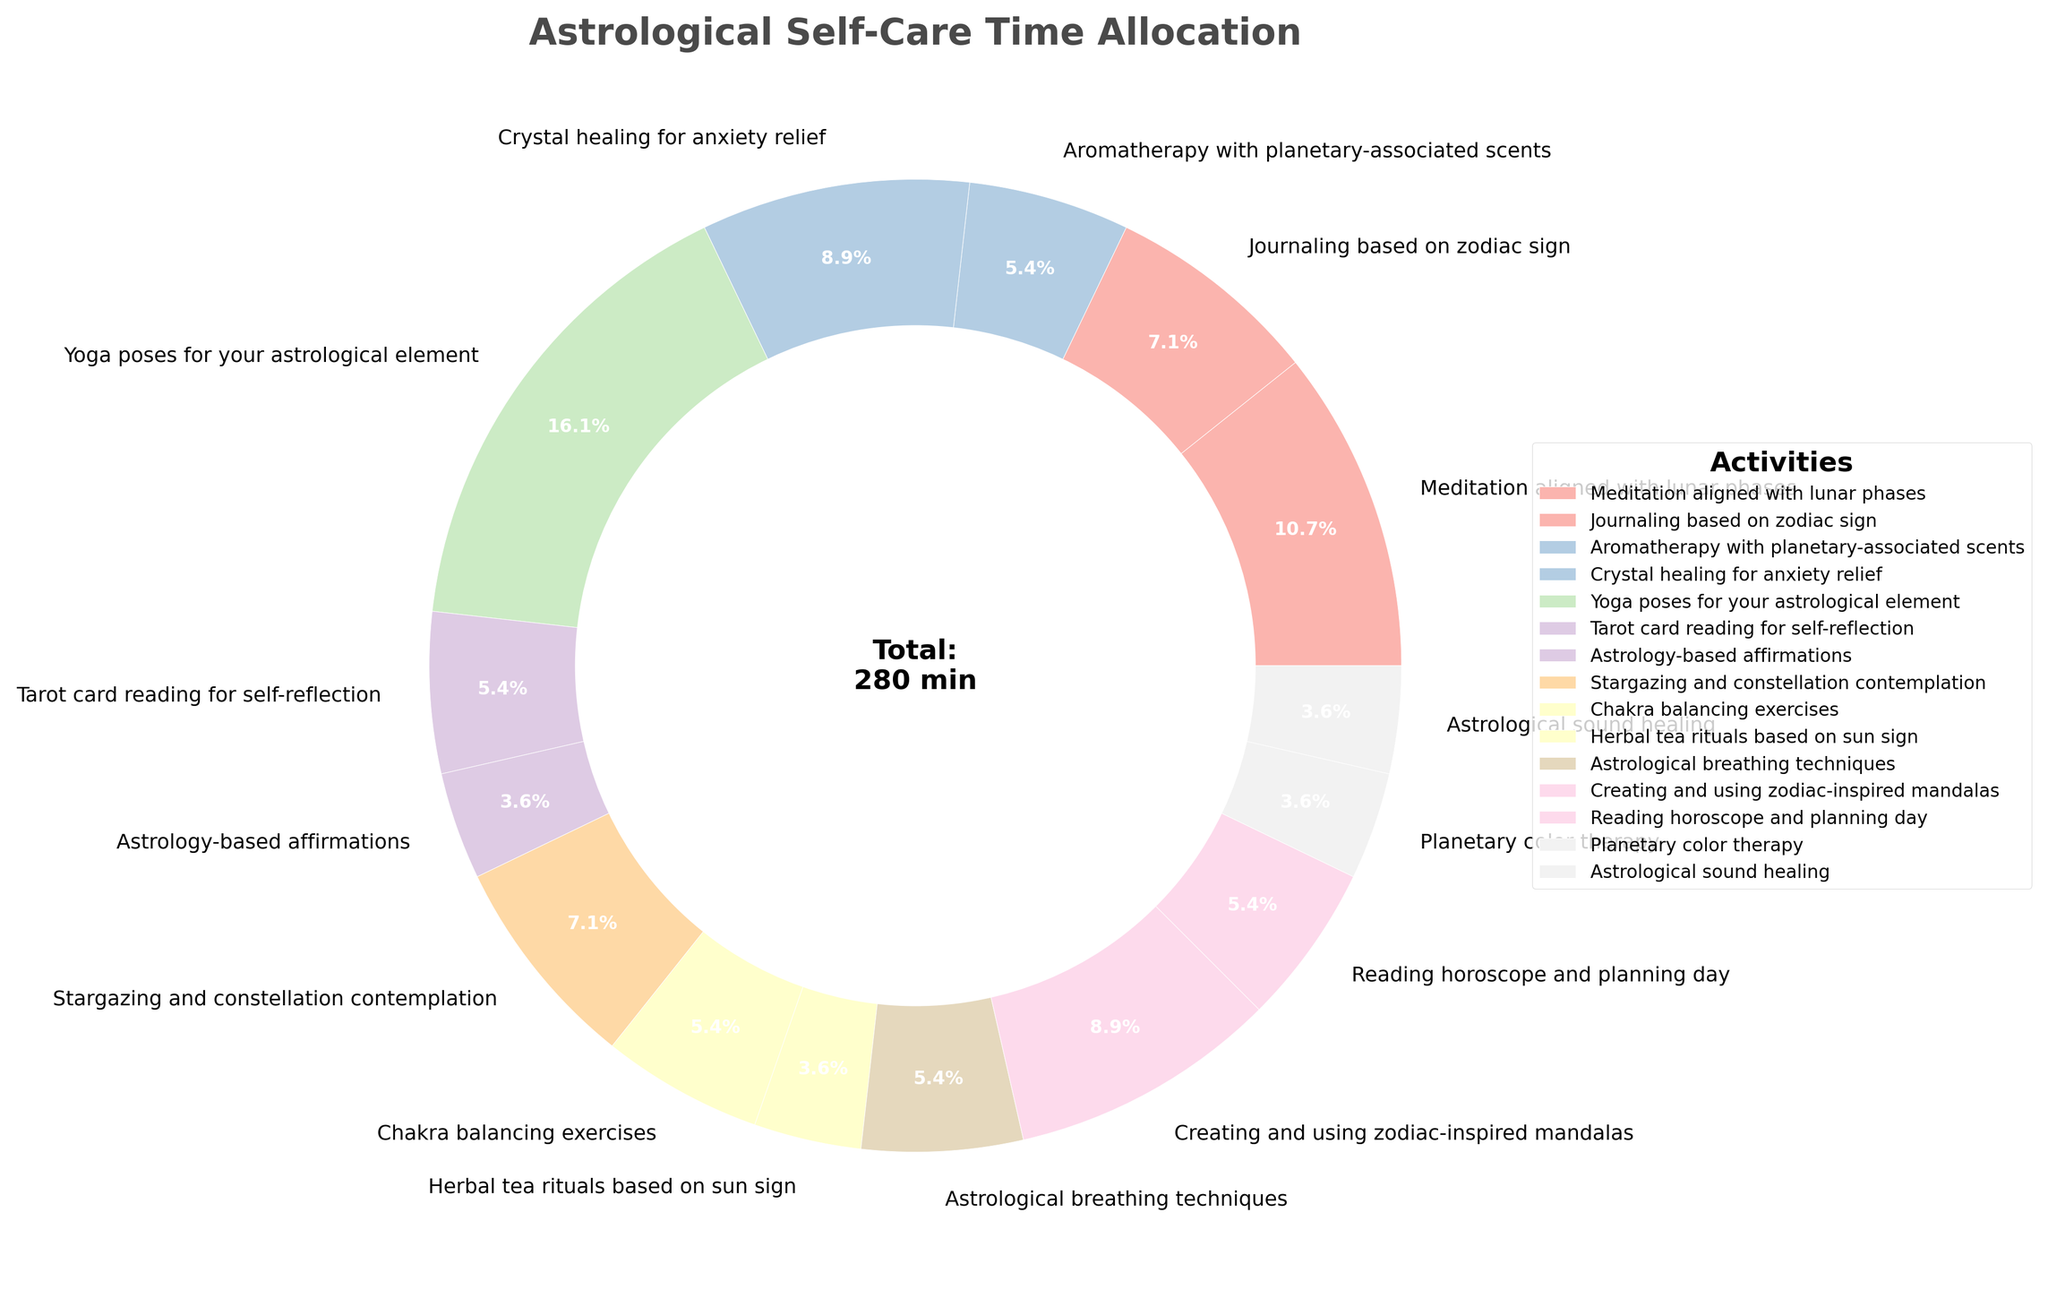What is the total time allocated for yoga poses for your astrological element and crystal healing for anxiety relief? To find the total time, sum the minutes for "yoga poses for your astrological element" (45) and "crystal healing for anxiety relief" (25). Total time = 45 + 25 = 70 minutes
Answer: 70 minutes Which activity has the highest time allocation? By observing the pie chart, the activity with the largest slice is "yoga poses for your astrological element," which is 45 minutes per day
Answer: Yoga poses for your astrological element What percentage of the total time is dedicated to journaling based on zodiac sign? According to the pie chart, journaling based on zodiac sign is 20 minutes per day. The total time per day is the sum of all time allocations (255 minutes), so the percentage is (20/255) * 100 ≈ 7.8%
Answer: 7.8% Which activity takes up more time: stargazing and constellation contemplation or astrological breathing techniques? Stargazing and constellation contemplation is 20 minutes, while astrological breathing techniques is 15 minutes. Therefore, stargazing and constellation contemplation takes more time
Answer: Stargazing and constellation contemplation How much more time is allocated to meditation aligned with lunar phases compared to tarot card reading for self-reflection? Meditation aligned with lunar phases is allocated 30 minutes, and tarot card reading for self-reflection is 15 minutes. The difference is 30 - 15 = 15 minutes
Answer: 15 minutes What is the total percentage of time allocated to aromatherapy with planetary-associated scents, astrological sound healing, and planetary color therapy combined? The allocated times are 15, 10, and 10 minutes respectively. The total time is 15 + 10 + 10 = 35 minutes. The percentage is (35/255) * 100 ≈ 13.7%
Answer: 13.7% Are chakra balancing exercises allocated more or less time than creating and using zodiac-inspired mandalas? Chakra balancing exercises are allocated 15 minutes, and creating and using zodiac-inspired mandalas are allocated 25 minutes. Therefore, chakra balancing exercises are allocated less time
Answer: Less What is the smallest time allocation for any activity, and what is that activity? The smallest time allocation is tied between multiple activities: astrology-based affirmations, herbal tea rituals based on sun sign, planetary color therapy, and astrological sound healing, each allocated 10 minutes
Answer: Astrology-based affirmations, Herbal tea rituals based on sun sign, Planetary color therapy, and Astrological sound healing (each 10 minutes) What visual attribute indicates the proportion of time spent on each self-care activity? The size of the pie slices in the chart visually indicates the proportion of time spent on each self-care activity
Answer: Size of the pie slices 